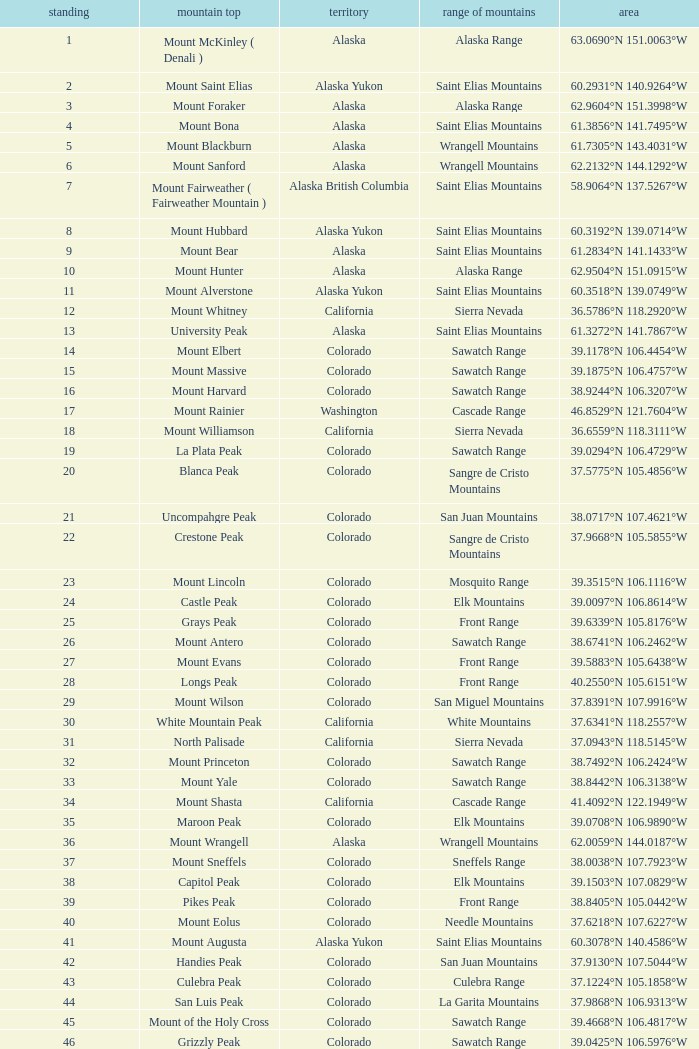What is the mountain range when the state is colorado, rank is higher than 90 and mountain peak is whetstone mountain? West Elk Mountains. 